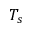Convert formula to latex. <formula><loc_0><loc_0><loc_500><loc_500>T _ { s }</formula> 